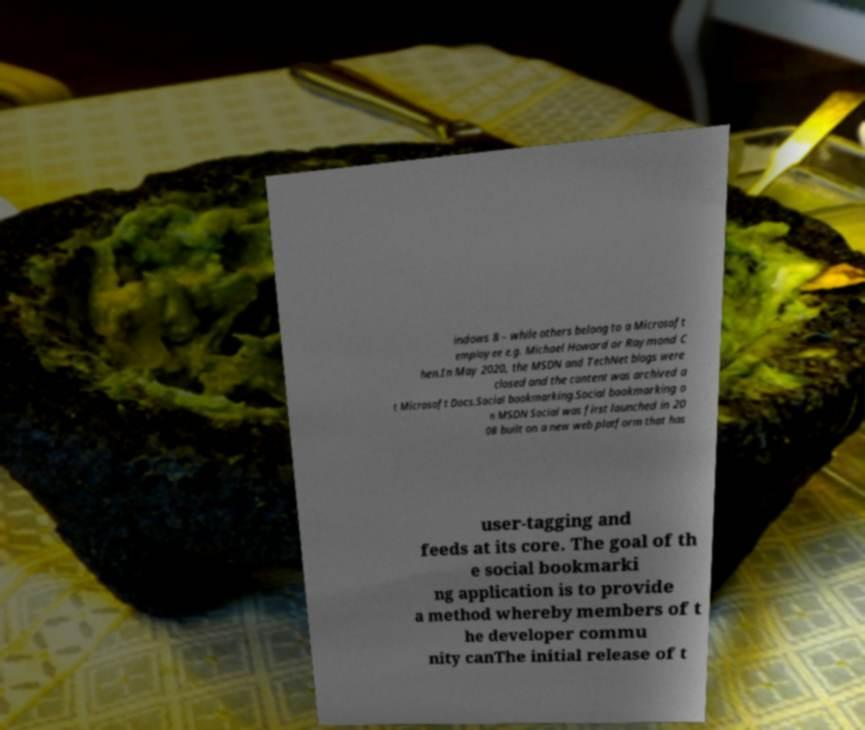Can you read and provide the text displayed in the image?This photo seems to have some interesting text. Can you extract and type it out for me? indows 8 – while others belong to a Microsoft employee e.g. Michael Howard or Raymond C hen.In May 2020, the MSDN and TechNet blogs were closed and the content was archived a t Microsoft Docs.Social bookmarking.Social bookmarking o n MSDN Social was first launched in 20 08 built on a new web platform that has user-tagging and feeds at its core. The goal of th e social bookmarki ng application is to provide a method whereby members of t he developer commu nity canThe initial release of t 